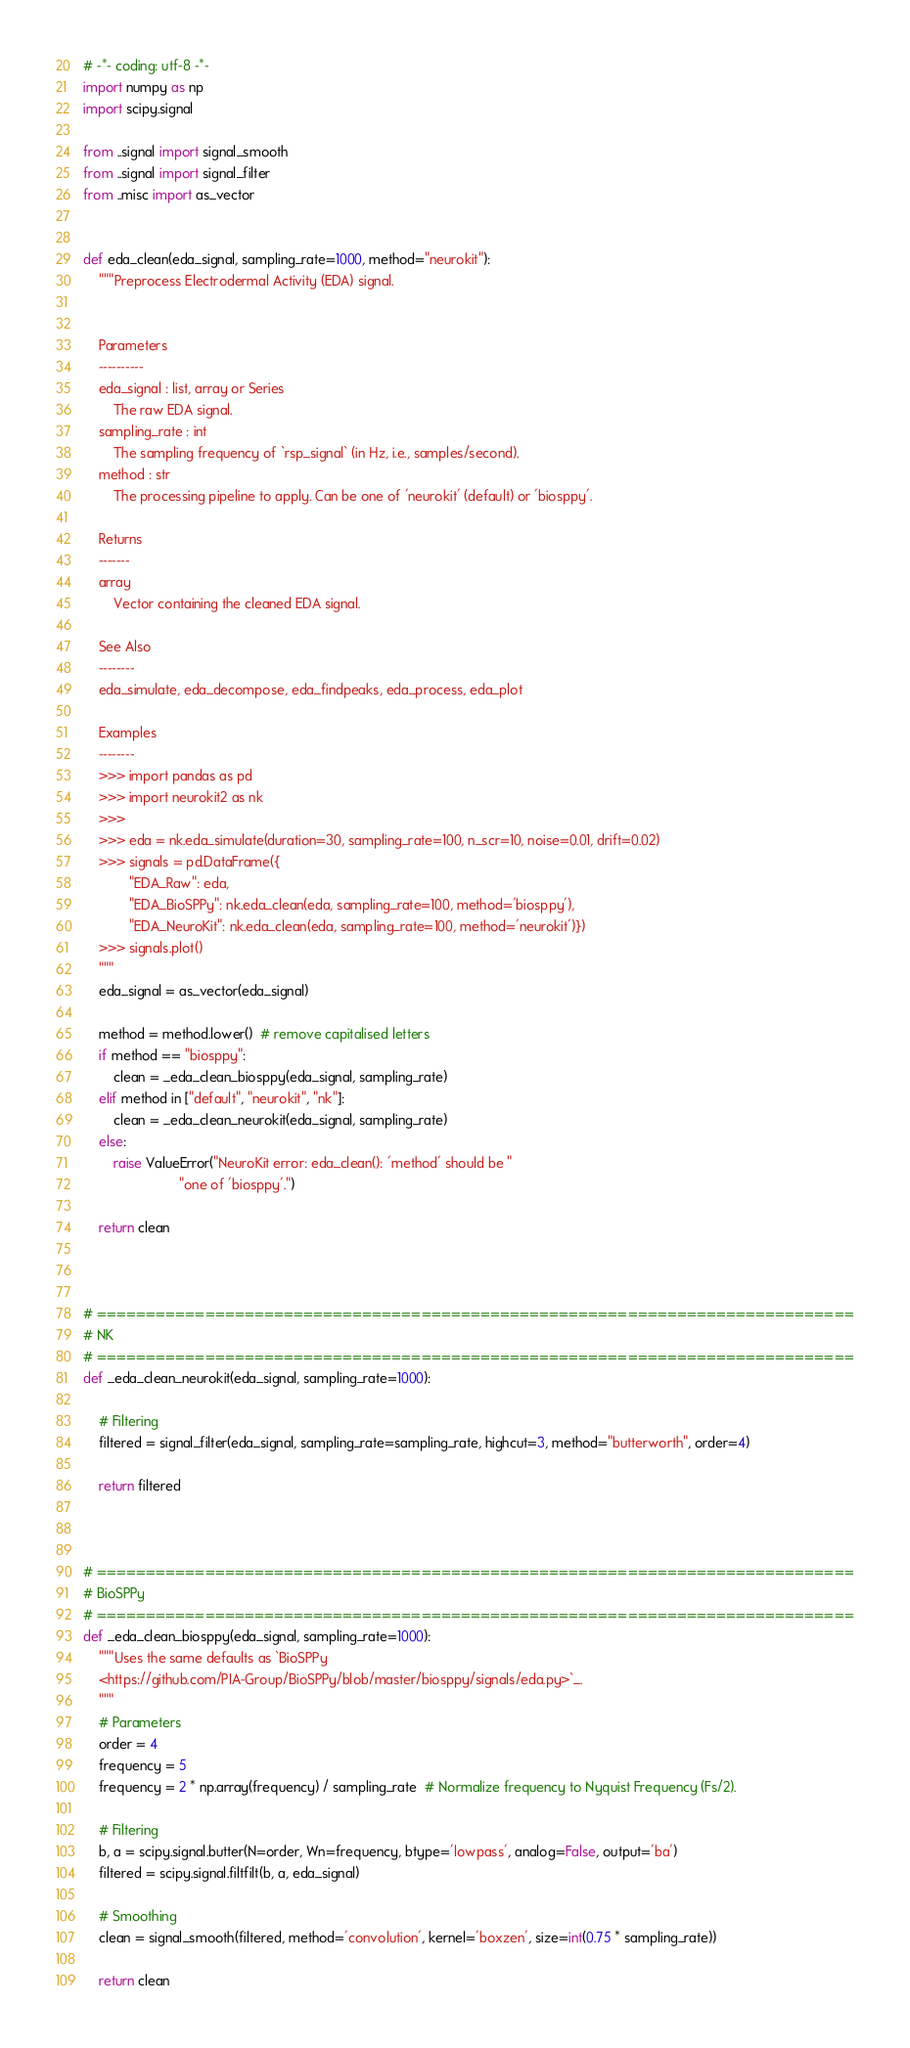<code> <loc_0><loc_0><loc_500><loc_500><_Python_># -*- coding: utf-8 -*-
import numpy as np
import scipy.signal

from ..signal import signal_smooth
from ..signal import signal_filter
from ..misc import as_vector


def eda_clean(eda_signal, sampling_rate=1000, method="neurokit"):
    """Preprocess Electrodermal Activity (EDA) signal.


    Parameters
    ----------
    eda_signal : list, array or Series
        The raw EDA signal.
    sampling_rate : int
        The sampling frequency of `rsp_signal` (in Hz, i.e., samples/second).
    method : str
        The processing pipeline to apply. Can be one of 'neurokit' (default) or 'biosppy'.

    Returns
    -------
    array
        Vector containing the cleaned EDA signal.

    See Also
    --------
    eda_simulate, eda_decompose, eda_findpeaks, eda_process, eda_plot

    Examples
    --------
    >>> import pandas as pd
    >>> import neurokit2 as nk
    >>>
    >>> eda = nk.eda_simulate(duration=30, sampling_rate=100, n_scr=10, noise=0.01, drift=0.02)
    >>> signals = pd.DataFrame({
            "EDA_Raw": eda,
            "EDA_BioSPPy": nk.eda_clean(eda, sampling_rate=100, method='biosppy'),
            "EDA_NeuroKit": nk.eda_clean(eda, sampling_rate=100, method='neurokit')})
    >>> signals.plot()
    """
    eda_signal = as_vector(eda_signal)

    method = method.lower()  # remove capitalised letters
    if method == "biosppy":
        clean = _eda_clean_biosppy(eda_signal, sampling_rate)
    elif method in ["default", "neurokit", "nk"]:
        clean = _eda_clean_neurokit(eda_signal, sampling_rate)
    else:
        raise ValueError("NeuroKit error: eda_clean(): 'method' should be "
                         "one of 'biosppy'.")

    return clean



# =============================================================================
# NK
# =============================================================================
def _eda_clean_neurokit(eda_signal, sampling_rate=1000):

    # Filtering
    filtered = signal_filter(eda_signal, sampling_rate=sampling_rate, highcut=3, method="butterworth", order=4)

    return filtered



# =============================================================================
# BioSPPy
# =============================================================================
def _eda_clean_biosppy(eda_signal, sampling_rate=1000):
    """Uses the same defaults as `BioSPPy
    <https://github.com/PIA-Group/BioSPPy/blob/master/biosppy/signals/eda.py>`_.
    """
    # Parameters
    order = 4
    frequency = 5
    frequency = 2 * np.array(frequency) / sampling_rate  # Normalize frequency to Nyquist Frequency (Fs/2).

    # Filtering
    b, a = scipy.signal.butter(N=order, Wn=frequency, btype='lowpass', analog=False, output='ba')
    filtered = scipy.signal.filtfilt(b, a, eda_signal)

    # Smoothing
    clean = signal_smooth(filtered, method='convolution', kernel='boxzen', size=int(0.75 * sampling_rate))

    return clean
</code> 